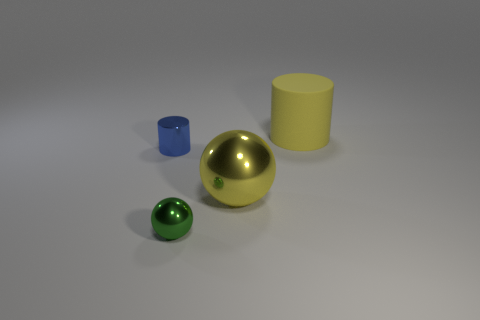Add 1 tiny cylinders. How many objects exist? 5 Subtract all yellow metallic balls. Subtract all big yellow matte cylinders. How many objects are left? 2 Add 3 tiny blue cylinders. How many tiny blue cylinders are left? 4 Add 1 large yellow objects. How many large yellow objects exist? 3 Subtract 0 yellow cubes. How many objects are left? 4 